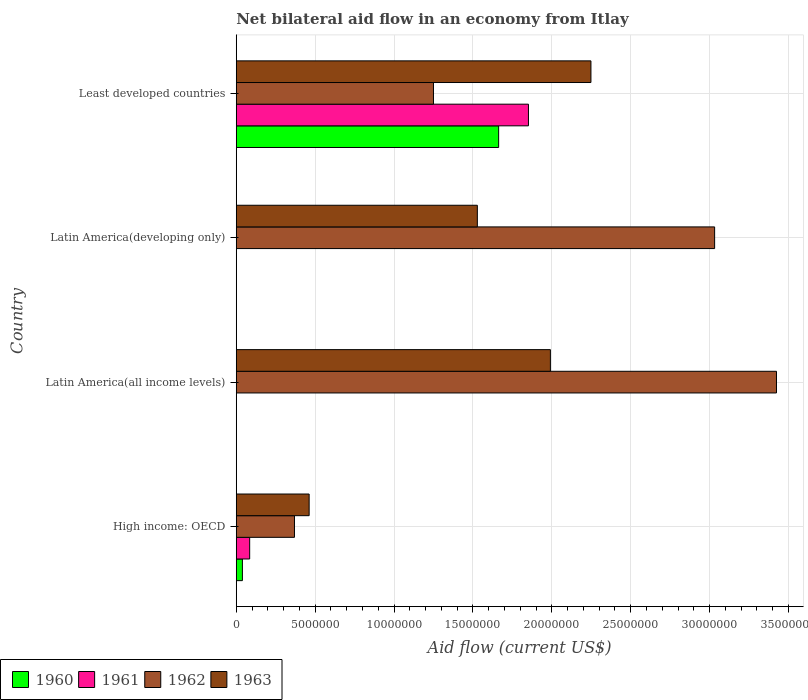How many different coloured bars are there?
Ensure brevity in your answer.  4. Are the number of bars per tick equal to the number of legend labels?
Offer a very short reply. No. Are the number of bars on each tick of the Y-axis equal?
Give a very brief answer. No. How many bars are there on the 4th tick from the bottom?
Provide a short and direct response. 4. What is the label of the 4th group of bars from the top?
Offer a terse response. High income: OECD. In how many cases, is the number of bars for a given country not equal to the number of legend labels?
Provide a short and direct response. 2. What is the net bilateral aid flow in 1962 in High income: OECD?
Your answer should be compact. 3.69e+06. Across all countries, what is the maximum net bilateral aid flow in 1963?
Give a very brief answer. 2.25e+07. Across all countries, what is the minimum net bilateral aid flow in 1960?
Keep it short and to the point. 0. In which country was the net bilateral aid flow in 1960 maximum?
Ensure brevity in your answer.  Least developed countries. What is the total net bilateral aid flow in 1960 in the graph?
Make the answer very short. 1.70e+07. What is the difference between the net bilateral aid flow in 1963 in High income: OECD and that in Least developed countries?
Provide a short and direct response. -1.79e+07. What is the difference between the net bilateral aid flow in 1962 in Latin America(all income levels) and the net bilateral aid flow in 1961 in Latin America(developing only)?
Your answer should be very brief. 3.42e+07. What is the average net bilateral aid flow in 1962 per country?
Your answer should be very brief. 2.02e+07. What is the difference between the net bilateral aid flow in 1963 and net bilateral aid flow in 1962 in Latin America(developing only)?
Ensure brevity in your answer.  -1.50e+07. What is the ratio of the net bilateral aid flow in 1963 in Latin America(all income levels) to that in Least developed countries?
Keep it short and to the point. 0.89. What is the difference between the highest and the second highest net bilateral aid flow in 1963?
Your response must be concise. 2.57e+06. What is the difference between the highest and the lowest net bilateral aid flow in 1961?
Make the answer very short. 1.85e+07. In how many countries, is the net bilateral aid flow in 1960 greater than the average net bilateral aid flow in 1960 taken over all countries?
Provide a short and direct response. 1. Is the sum of the net bilateral aid flow in 1961 in High income: OECD and Least developed countries greater than the maximum net bilateral aid flow in 1962 across all countries?
Provide a short and direct response. No. How many bars are there?
Offer a very short reply. 12. What is the difference between two consecutive major ticks on the X-axis?
Make the answer very short. 5.00e+06. Are the values on the major ticks of X-axis written in scientific E-notation?
Give a very brief answer. No. Where does the legend appear in the graph?
Ensure brevity in your answer.  Bottom left. What is the title of the graph?
Make the answer very short. Net bilateral aid flow in an economy from Itlay. What is the label or title of the X-axis?
Keep it short and to the point. Aid flow (current US$). What is the label or title of the Y-axis?
Offer a terse response. Country. What is the Aid flow (current US$) in 1961 in High income: OECD?
Your answer should be compact. 8.50e+05. What is the Aid flow (current US$) of 1962 in High income: OECD?
Make the answer very short. 3.69e+06. What is the Aid flow (current US$) in 1963 in High income: OECD?
Provide a succinct answer. 4.62e+06. What is the Aid flow (current US$) in 1960 in Latin America(all income levels)?
Offer a very short reply. 0. What is the Aid flow (current US$) of 1961 in Latin America(all income levels)?
Your answer should be compact. 0. What is the Aid flow (current US$) of 1962 in Latin America(all income levels)?
Provide a succinct answer. 3.42e+07. What is the Aid flow (current US$) in 1963 in Latin America(all income levels)?
Keep it short and to the point. 1.99e+07. What is the Aid flow (current US$) of 1961 in Latin America(developing only)?
Your answer should be very brief. 0. What is the Aid flow (current US$) of 1962 in Latin America(developing only)?
Make the answer very short. 3.03e+07. What is the Aid flow (current US$) of 1963 in Latin America(developing only)?
Your answer should be very brief. 1.53e+07. What is the Aid flow (current US$) in 1960 in Least developed countries?
Your response must be concise. 1.66e+07. What is the Aid flow (current US$) in 1961 in Least developed countries?
Your response must be concise. 1.85e+07. What is the Aid flow (current US$) of 1962 in Least developed countries?
Your answer should be very brief. 1.25e+07. What is the Aid flow (current US$) of 1963 in Least developed countries?
Your answer should be compact. 2.25e+07. Across all countries, what is the maximum Aid flow (current US$) in 1960?
Provide a short and direct response. 1.66e+07. Across all countries, what is the maximum Aid flow (current US$) in 1961?
Provide a short and direct response. 1.85e+07. Across all countries, what is the maximum Aid flow (current US$) of 1962?
Ensure brevity in your answer.  3.42e+07. Across all countries, what is the maximum Aid flow (current US$) in 1963?
Your answer should be very brief. 2.25e+07. Across all countries, what is the minimum Aid flow (current US$) of 1960?
Provide a succinct answer. 0. Across all countries, what is the minimum Aid flow (current US$) in 1962?
Ensure brevity in your answer.  3.69e+06. Across all countries, what is the minimum Aid flow (current US$) in 1963?
Your response must be concise. 4.62e+06. What is the total Aid flow (current US$) in 1960 in the graph?
Provide a succinct answer. 1.70e+07. What is the total Aid flow (current US$) of 1961 in the graph?
Your response must be concise. 1.94e+07. What is the total Aid flow (current US$) of 1962 in the graph?
Ensure brevity in your answer.  8.08e+07. What is the total Aid flow (current US$) of 1963 in the graph?
Make the answer very short. 6.23e+07. What is the difference between the Aid flow (current US$) of 1962 in High income: OECD and that in Latin America(all income levels)?
Your answer should be very brief. -3.06e+07. What is the difference between the Aid flow (current US$) in 1963 in High income: OECD and that in Latin America(all income levels)?
Offer a very short reply. -1.53e+07. What is the difference between the Aid flow (current US$) in 1962 in High income: OECD and that in Latin America(developing only)?
Offer a terse response. -2.66e+07. What is the difference between the Aid flow (current US$) of 1963 in High income: OECD and that in Latin America(developing only)?
Ensure brevity in your answer.  -1.07e+07. What is the difference between the Aid flow (current US$) of 1960 in High income: OECD and that in Least developed countries?
Provide a succinct answer. -1.62e+07. What is the difference between the Aid flow (current US$) in 1961 in High income: OECD and that in Least developed countries?
Your answer should be compact. -1.77e+07. What is the difference between the Aid flow (current US$) in 1962 in High income: OECD and that in Least developed countries?
Make the answer very short. -8.81e+06. What is the difference between the Aid flow (current US$) of 1963 in High income: OECD and that in Least developed countries?
Ensure brevity in your answer.  -1.79e+07. What is the difference between the Aid flow (current US$) of 1962 in Latin America(all income levels) and that in Latin America(developing only)?
Your response must be concise. 3.92e+06. What is the difference between the Aid flow (current US$) in 1963 in Latin America(all income levels) and that in Latin America(developing only)?
Keep it short and to the point. 4.63e+06. What is the difference between the Aid flow (current US$) in 1962 in Latin America(all income levels) and that in Least developed countries?
Offer a terse response. 2.17e+07. What is the difference between the Aid flow (current US$) of 1963 in Latin America(all income levels) and that in Least developed countries?
Offer a terse response. -2.57e+06. What is the difference between the Aid flow (current US$) in 1962 in Latin America(developing only) and that in Least developed countries?
Make the answer very short. 1.78e+07. What is the difference between the Aid flow (current US$) in 1963 in Latin America(developing only) and that in Least developed countries?
Offer a terse response. -7.20e+06. What is the difference between the Aid flow (current US$) in 1960 in High income: OECD and the Aid flow (current US$) in 1962 in Latin America(all income levels)?
Keep it short and to the point. -3.38e+07. What is the difference between the Aid flow (current US$) in 1960 in High income: OECD and the Aid flow (current US$) in 1963 in Latin America(all income levels)?
Provide a succinct answer. -1.95e+07. What is the difference between the Aid flow (current US$) of 1961 in High income: OECD and the Aid flow (current US$) of 1962 in Latin America(all income levels)?
Your response must be concise. -3.34e+07. What is the difference between the Aid flow (current US$) in 1961 in High income: OECD and the Aid flow (current US$) in 1963 in Latin America(all income levels)?
Give a very brief answer. -1.91e+07. What is the difference between the Aid flow (current US$) in 1962 in High income: OECD and the Aid flow (current US$) in 1963 in Latin America(all income levels)?
Give a very brief answer. -1.62e+07. What is the difference between the Aid flow (current US$) in 1960 in High income: OECD and the Aid flow (current US$) in 1962 in Latin America(developing only)?
Provide a short and direct response. -2.99e+07. What is the difference between the Aid flow (current US$) of 1960 in High income: OECD and the Aid flow (current US$) of 1963 in Latin America(developing only)?
Ensure brevity in your answer.  -1.49e+07. What is the difference between the Aid flow (current US$) in 1961 in High income: OECD and the Aid flow (current US$) in 1962 in Latin America(developing only)?
Give a very brief answer. -2.95e+07. What is the difference between the Aid flow (current US$) in 1961 in High income: OECD and the Aid flow (current US$) in 1963 in Latin America(developing only)?
Offer a very short reply. -1.44e+07. What is the difference between the Aid flow (current US$) of 1962 in High income: OECD and the Aid flow (current US$) of 1963 in Latin America(developing only)?
Provide a succinct answer. -1.16e+07. What is the difference between the Aid flow (current US$) of 1960 in High income: OECD and the Aid flow (current US$) of 1961 in Least developed countries?
Your answer should be compact. -1.81e+07. What is the difference between the Aid flow (current US$) in 1960 in High income: OECD and the Aid flow (current US$) in 1962 in Least developed countries?
Your answer should be very brief. -1.21e+07. What is the difference between the Aid flow (current US$) of 1960 in High income: OECD and the Aid flow (current US$) of 1963 in Least developed countries?
Provide a short and direct response. -2.21e+07. What is the difference between the Aid flow (current US$) of 1961 in High income: OECD and the Aid flow (current US$) of 1962 in Least developed countries?
Offer a very short reply. -1.16e+07. What is the difference between the Aid flow (current US$) of 1961 in High income: OECD and the Aid flow (current US$) of 1963 in Least developed countries?
Give a very brief answer. -2.16e+07. What is the difference between the Aid flow (current US$) of 1962 in High income: OECD and the Aid flow (current US$) of 1963 in Least developed countries?
Provide a short and direct response. -1.88e+07. What is the difference between the Aid flow (current US$) in 1962 in Latin America(all income levels) and the Aid flow (current US$) in 1963 in Latin America(developing only)?
Your answer should be compact. 1.90e+07. What is the difference between the Aid flow (current US$) of 1962 in Latin America(all income levels) and the Aid flow (current US$) of 1963 in Least developed countries?
Your response must be concise. 1.18e+07. What is the difference between the Aid flow (current US$) in 1962 in Latin America(developing only) and the Aid flow (current US$) in 1963 in Least developed countries?
Provide a short and direct response. 7.84e+06. What is the average Aid flow (current US$) in 1960 per country?
Provide a short and direct response. 4.26e+06. What is the average Aid flow (current US$) in 1961 per country?
Your answer should be compact. 4.84e+06. What is the average Aid flow (current US$) of 1962 per country?
Your answer should be very brief. 2.02e+07. What is the average Aid flow (current US$) in 1963 per country?
Provide a short and direct response. 1.56e+07. What is the difference between the Aid flow (current US$) in 1960 and Aid flow (current US$) in 1961 in High income: OECD?
Give a very brief answer. -4.60e+05. What is the difference between the Aid flow (current US$) of 1960 and Aid flow (current US$) of 1962 in High income: OECD?
Ensure brevity in your answer.  -3.30e+06. What is the difference between the Aid flow (current US$) in 1960 and Aid flow (current US$) in 1963 in High income: OECD?
Your response must be concise. -4.23e+06. What is the difference between the Aid flow (current US$) in 1961 and Aid flow (current US$) in 1962 in High income: OECD?
Provide a short and direct response. -2.84e+06. What is the difference between the Aid flow (current US$) of 1961 and Aid flow (current US$) of 1963 in High income: OECD?
Your answer should be very brief. -3.77e+06. What is the difference between the Aid flow (current US$) in 1962 and Aid flow (current US$) in 1963 in High income: OECD?
Give a very brief answer. -9.30e+05. What is the difference between the Aid flow (current US$) of 1962 and Aid flow (current US$) of 1963 in Latin America(all income levels)?
Provide a succinct answer. 1.43e+07. What is the difference between the Aid flow (current US$) of 1962 and Aid flow (current US$) of 1963 in Latin America(developing only)?
Provide a short and direct response. 1.50e+07. What is the difference between the Aid flow (current US$) in 1960 and Aid flow (current US$) in 1961 in Least developed countries?
Your answer should be compact. -1.89e+06. What is the difference between the Aid flow (current US$) of 1960 and Aid flow (current US$) of 1962 in Least developed countries?
Provide a succinct answer. 4.13e+06. What is the difference between the Aid flow (current US$) of 1960 and Aid flow (current US$) of 1963 in Least developed countries?
Give a very brief answer. -5.85e+06. What is the difference between the Aid flow (current US$) in 1961 and Aid flow (current US$) in 1962 in Least developed countries?
Offer a terse response. 6.02e+06. What is the difference between the Aid flow (current US$) of 1961 and Aid flow (current US$) of 1963 in Least developed countries?
Offer a very short reply. -3.96e+06. What is the difference between the Aid flow (current US$) of 1962 and Aid flow (current US$) of 1963 in Least developed countries?
Your response must be concise. -9.98e+06. What is the ratio of the Aid flow (current US$) of 1962 in High income: OECD to that in Latin America(all income levels)?
Your answer should be compact. 0.11. What is the ratio of the Aid flow (current US$) of 1963 in High income: OECD to that in Latin America(all income levels)?
Your answer should be very brief. 0.23. What is the ratio of the Aid flow (current US$) in 1962 in High income: OECD to that in Latin America(developing only)?
Your answer should be compact. 0.12. What is the ratio of the Aid flow (current US$) of 1963 in High income: OECD to that in Latin America(developing only)?
Give a very brief answer. 0.3. What is the ratio of the Aid flow (current US$) of 1960 in High income: OECD to that in Least developed countries?
Give a very brief answer. 0.02. What is the ratio of the Aid flow (current US$) in 1961 in High income: OECD to that in Least developed countries?
Provide a succinct answer. 0.05. What is the ratio of the Aid flow (current US$) in 1962 in High income: OECD to that in Least developed countries?
Provide a short and direct response. 0.3. What is the ratio of the Aid flow (current US$) in 1963 in High income: OECD to that in Least developed countries?
Offer a terse response. 0.21. What is the ratio of the Aid flow (current US$) of 1962 in Latin America(all income levels) to that in Latin America(developing only)?
Offer a terse response. 1.13. What is the ratio of the Aid flow (current US$) of 1963 in Latin America(all income levels) to that in Latin America(developing only)?
Your answer should be very brief. 1.3. What is the ratio of the Aid flow (current US$) in 1962 in Latin America(all income levels) to that in Least developed countries?
Your response must be concise. 2.74. What is the ratio of the Aid flow (current US$) in 1963 in Latin America(all income levels) to that in Least developed countries?
Provide a succinct answer. 0.89. What is the ratio of the Aid flow (current US$) in 1962 in Latin America(developing only) to that in Least developed countries?
Your response must be concise. 2.43. What is the ratio of the Aid flow (current US$) in 1963 in Latin America(developing only) to that in Least developed countries?
Give a very brief answer. 0.68. What is the difference between the highest and the second highest Aid flow (current US$) of 1962?
Provide a succinct answer. 3.92e+06. What is the difference between the highest and the second highest Aid flow (current US$) of 1963?
Give a very brief answer. 2.57e+06. What is the difference between the highest and the lowest Aid flow (current US$) of 1960?
Make the answer very short. 1.66e+07. What is the difference between the highest and the lowest Aid flow (current US$) in 1961?
Your answer should be compact. 1.85e+07. What is the difference between the highest and the lowest Aid flow (current US$) in 1962?
Make the answer very short. 3.06e+07. What is the difference between the highest and the lowest Aid flow (current US$) of 1963?
Ensure brevity in your answer.  1.79e+07. 